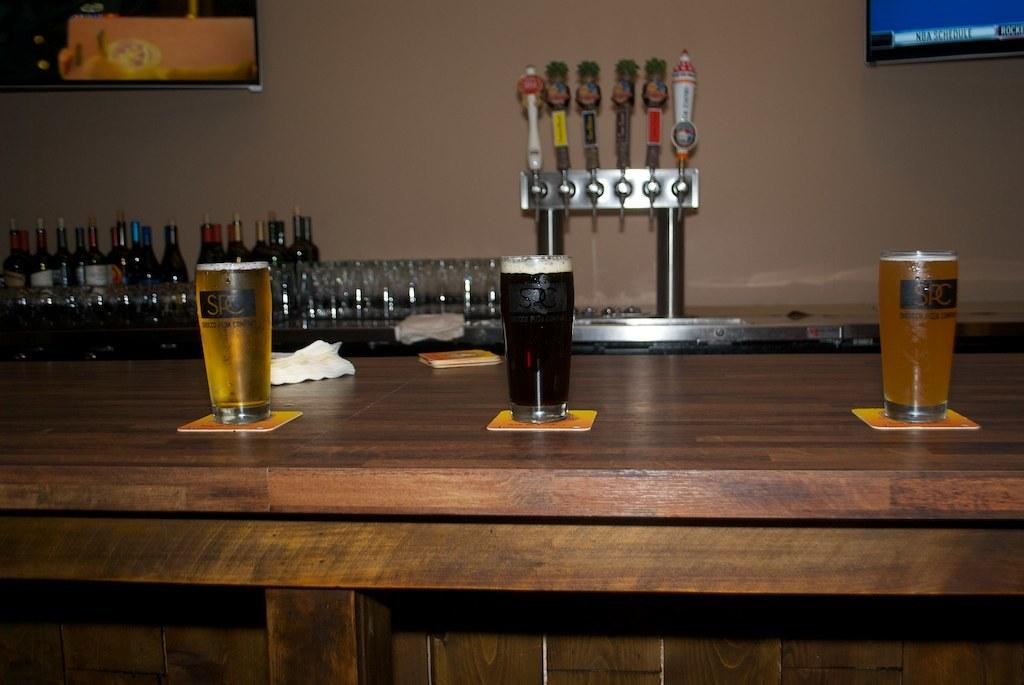What objects are on the table in the image? There are different types of glasses on the table. Can you describe the objects visible in the background of the image? There are glasses and bottles visible in the background of the image. Who is the expert in the image? There is no expert present in the image. What type of tin can be seen in the image? There is no tin present in the image. 